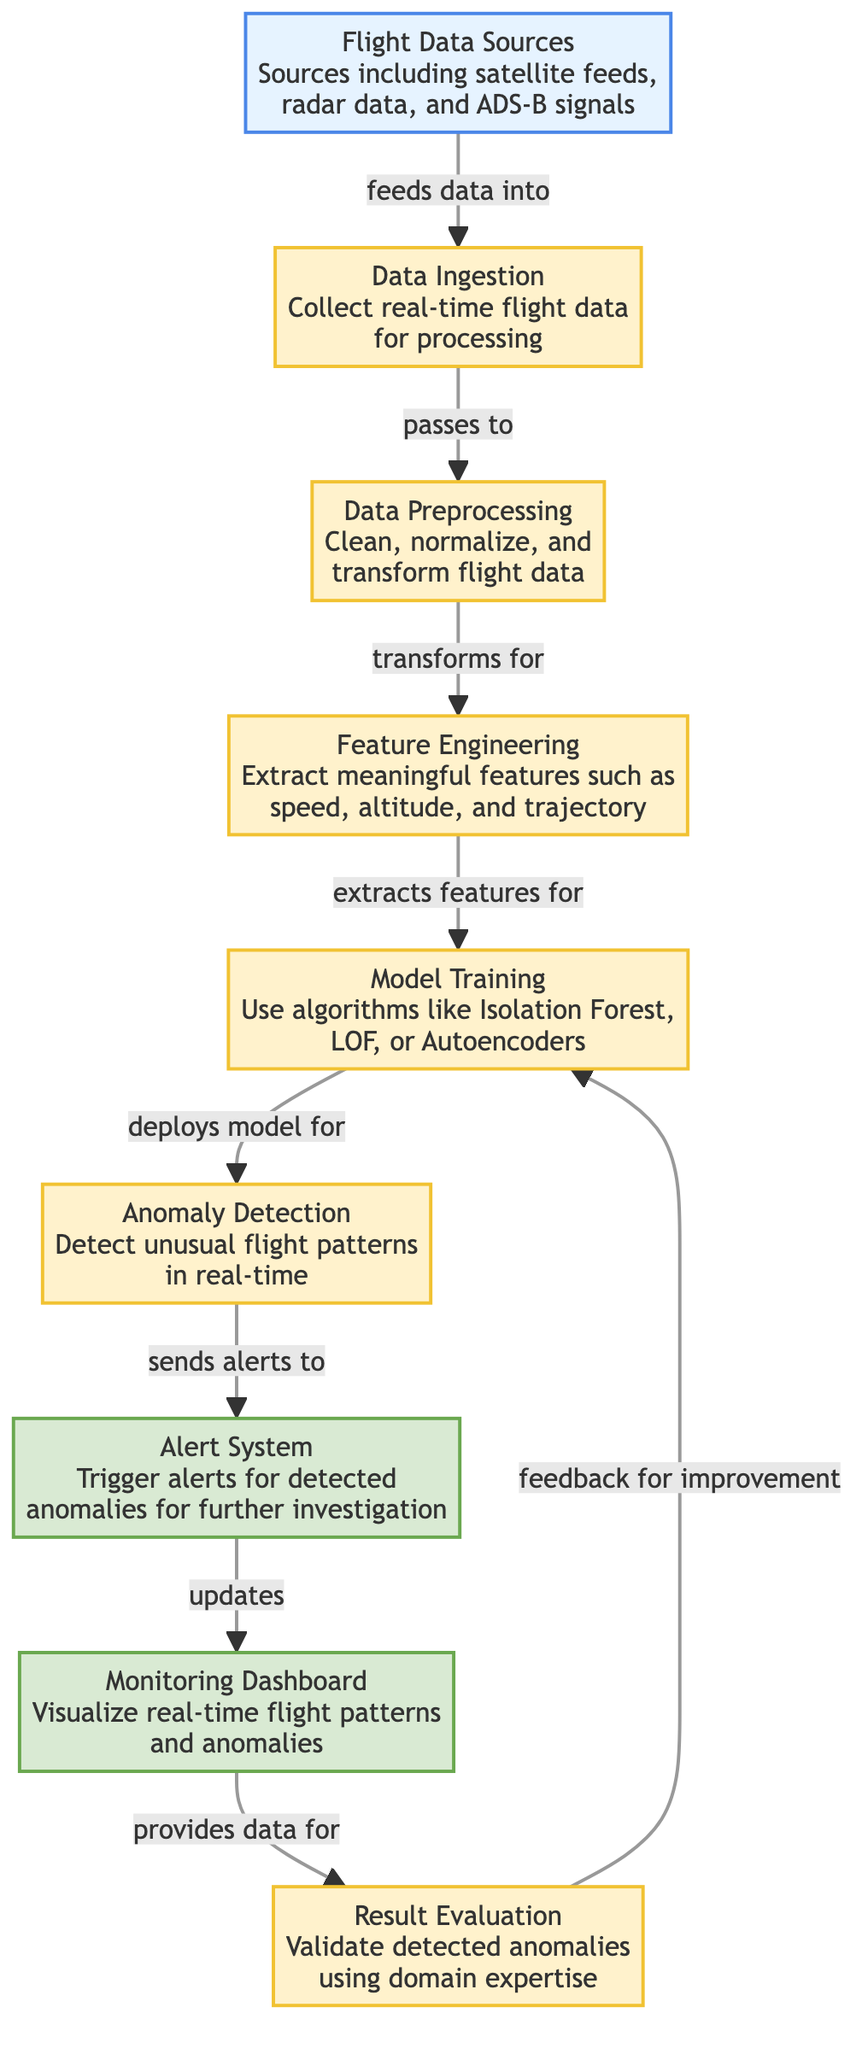What are the flight data sources mentioned in the diagram? The node labeled "Flight Data Sources" lists satellite feeds, radar data, and ADS-B signals. This information is a direct extraction from the diagram's data source node.
Answer: Satellite feeds, radar data, and ADS-B signals How many main process steps are there from data ingestion to result evaluation? The main process steps include data ingestion, data preprocessing, feature engineering, model training, anomaly detection, and result evaluation. Counting these nodes yields a total of six distinct process steps.
Answer: Six What type of system is triggered upon the detection of anomalies? The node labeled "Alert System" indicates that alerts are triggered for detected anomalies. This describes the specific function that takes place as part of the workflow.
Answer: Alert System Which node is responsible for visualizing real-time flight patterns and anomalies? The "Monitoring Dashboard" node serves the purpose of visualizing real-time flight patterns and anomalies, as explicitly mentioned in the diagram.
Answer: Monitoring Dashboard What happens to the alerts generated in the anomaly detection process? The arrow from the anomaly detection node indicates that alerts are sent to the alert system. This establishes a direct relationship where detected anomalies prompt the creation of alerts.
Answer: Sends alerts to alert system Which step comes immediately after feature engineering in the workflow? In the diagram, the step that follows directly after feature engineering is model training. This flow is clearly indicated by the directed arrow connecting these two nodes.
Answer: Model Training How does the result evaluation process contribute to overall model improvement? The arrow from the result evaluation node indicates that it provides feedback for improvement to model training, establishing a cyclical relationship aimed at model enhancement.
Answer: Feedback for improvement What machine learning algorithms are mentioned for model training? The node labeled "Model Training" specifies that algorithms like Isolation Forest, LOF, or Autoencoders are used for training the model. This detail is an integral part of understanding the machine learning approach taken in the workflow.
Answer: Isolation Forest, LOF, Autoencoders How does the data ingestion step relate to flight data sources? The arrow from flight data sources to data ingestion specifies that it feeds data into the data ingestion process, indicating a directional flow of information essential for subsequent steps.
Answer: Feeds data into data ingestion 